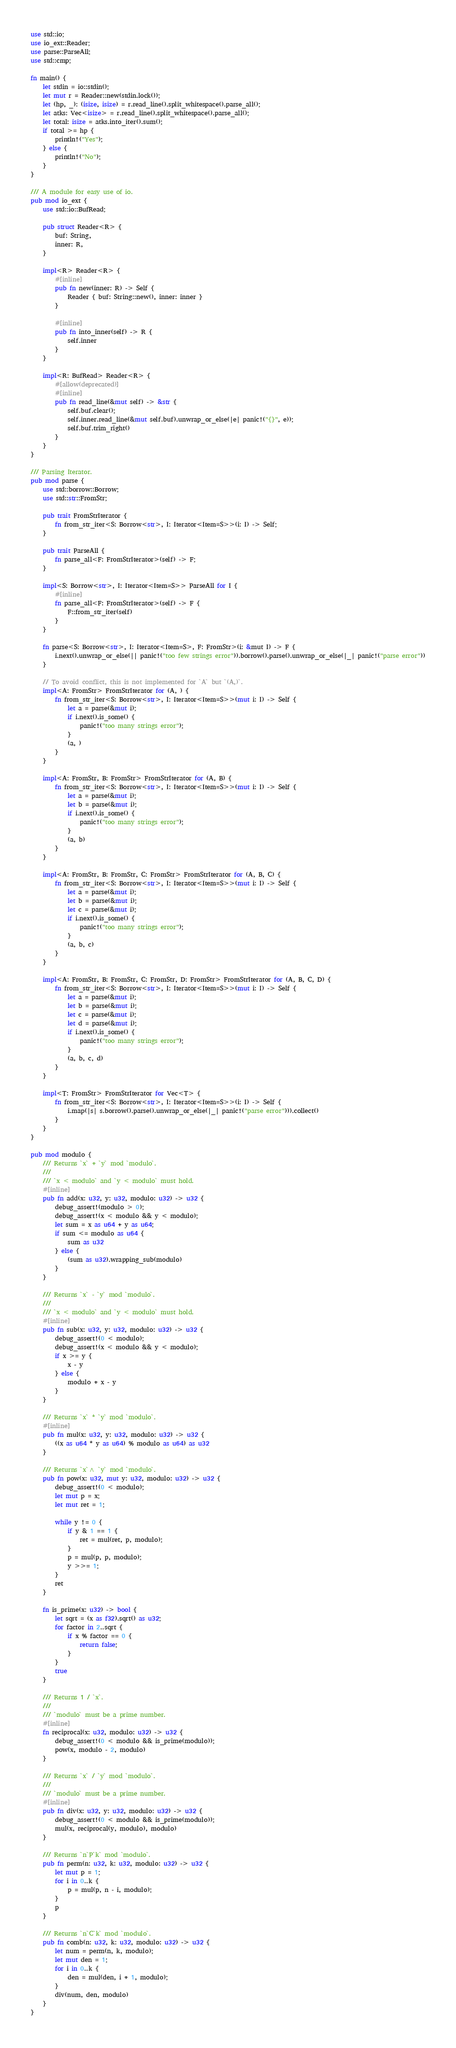<code> <loc_0><loc_0><loc_500><loc_500><_Rust_>use std::io;
use io_ext::Reader;
use parse::ParseAll;
use std::cmp;

fn main() {
    let stdin = io::stdin();
    let mut r = Reader::new(stdin.lock());
    let (hp, _): (isize, isize) = r.read_line().split_whitespace().parse_all();
    let atks: Vec<isize> = r.read_line().split_whitespace().parse_all();
    let total: isize = atks.into_iter().sum();
    if total >= hp {
        println!("Yes");
    } else {
        println!("No");
    }
}

/// A module for easy use of io.
pub mod io_ext {
    use std::io::BufRead;

    pub struct Reader<R> {
        buf: String,
        inner: R,
    }

    impl<R> Reader<R> {
        #[inline]
        pub fn new(inner: R) -> Self {
            Reader { buf: String::new(), inner: inner }
        }

        #[inline]
        pub fn into_inner(self) -> R {
            self.inner
        }
    }

    impl<R: BufRead> Reader<R> {
        #[allow(deprecated)]
        #[inline]
        pub fn read_line(&mut self) -> &str {
            self.buf.clear();
            self.inner.read_line(&mut self.buf).unwrap_or_else(|e| panic!("{}", e));
            self.buf.trim_right()
        }
    }
}

/// Parsing Iterator.
pub mod parse {
    use std::borrow::Borrow;
    use std::str::FromStr;

    pub trait FromStrIterator {
        fn from_str_iter<S: Borrow<str>, I: Iterator<Item=S>>(i: I) -> Self;
    }

    pub trait ParseAll {
        fn parse_all<F: FromStrIterator>(self) -> F;
    }

    impl<S: Borrow<str>, I: Iterator<Item=S>> ParseAll for I {
        #[inline]
        fn parse_all<F: FromStrIterator>(self) -> F {
            F::from_str_iter(self)
        }
    }

    fn parse<S: Borrow<str>, I: Iterator<Item=S>, F: FromStr>(i: &mut I) -> F {
        i.next().unwrap_or_else(|| panic!("too few strings error")).borrow().parse().unwrap_or_else(|_| panic!("parse error"))
    }

    // To avoid conflict, this is not implemented for `A` but `(A,)`.
    impl<A: FromStr> FromStrIterator for (A, ) {
        fn from_str_iter<S: Borrow<str>, I: Iterator<Item=S>>(mut i: I) -> Self {
            let a = parse(&mut i);
            if i.next().is_some() {
                panic!("too many strings error");
            }
            (a, )
        }
    }

    impl<A: FromStr, B: FromStr> FromStrIterator for (A, B) {
        fn from_str_iter<S: Borrow<str>, I: Iterator<Item=S>>(mut i: I) -> Self {
            let a = parse(&mut i);
            let b = parse(&mut i);
            if i.next().is_some() {
                panic!("too many strings error");
            }
            (a, b)
        }
    }

    impl<A: FromStr, B: FromStr, C: FromStr> FromStrIterator for (A, B, C) {
        fn from_str_iter<S: Borrow<str>, I: Iterator<Item=S>>(mut i: I) -> Self {
            let a = parse(&mut i);
            let b = parse(&mut i);
            let c = parse(&mut i);
            if i.next().is_some() {
                panic!("too many strings error");
            }
            (a, b, c)
        }
    }

    impl<A: FromStr, B: FromStr, C: FromStr, D: FromStr> FromStrIterator for (A, B, C, D) {
        fn from_str_iter<S: Borrow<str>, I: Iterator<Item=S>>(mut i: I) -> Self {
            let a = parse(&mut i);
            let b = parse(&mut i);
            let c = parse(&mut i);
            let d = parse(&mut i);
            if i.next().is_some() {
                panic!("too many strings error");
            }
            (a, b, c, d)
        }
    }

    impl<T: FromStr> FromStrIterator for Vec<T> {
        fn from_str_iter<S: Borrow<str>, I: Iterator<Item=S>>(i: I) -> Self {
            i.map(|s| s.borrow().parse().unwrap_or_else(|_| panic!("parse error"))).collect()
        }
    }
}

pub mod modulo {
    /// Returns `x` + `y` mod `modulo`.
    ///
    /// `x < modulo` and `y < modulo` must hold.
    #[inline]
    pub fn add(x: u32, y: u32, modulo: u32) -> u32 {
        debug_assert!(modulo > 0);
        debug_assert!(x < modulo && y < modulo);
        let sum = x as u64 + y as u64;
        if sum <= modulo as u64 {
            sum as u32
        } else {
            (sum as u32).wrapping_sub(modulo)
        }
    }

    /// Returns `x` - `y` mod `modulo`.
    ///
    /// `x < modulo` and `y < modulo` must hold.
    #[inline]
    pub fn sub(x: u32, y: u32, modulo: u32) -> u32 {
        debug_assert!(0 < modulo);
        debug_assert!(x < modulo && y < modulo);
        if x >= y {
            x - y
        } else {
            modulo + x - y
        }
    }

    /// Returns `x` * `y` mod `modulo`.
    #[inline]
    pub fn mul(x: u32, y: u32, modulo: u32) -> u32 {
        ((x as u64 * y as u64) % modulo as u64) as u32
    }

    /// Returns `x`^ `y` mod `modulo`.
    pub fn pow(x: u32, mut y: u32, modulo: u32) -> u32 {
        debug_assert!(0 < modulo);
        let mut p = x;
        let mut ret = 1;

        while y != 0 {
            if y & 1 == 1 {
                ret = mul(ret, p, modulo);
            }
            p = mul(p, p, modulo);
            y >>= 1;
        }
        ret
    }

    fn is_prime(x: u32) -> bool {
        let sqrt = (x as f32).sqrt() as u32;
        for factor in 2..sqrt {
            if x % factor == 0 {
                return false;
            }
        }
        true
    }

    /// Returns 1 / `x`.
    ///
    /// `modulo` must be a prime number.
    #[inline]
    fn reciprocal(x: u32, modulo: u32) -> u32 {
        debug_assert!(0 < modulo && is_prime(modulo));
        pow(x, modulo - 2, modulo)
    }

    /// Returns `x` / `y` mod `modulo`.
    ///
    /// `modulo` must be a prime number.
    #[inline]
    pub fn div(x: u32, y: u32, modulo: u32) -> u32 {
        debug_assert!(0 < modulo && is_prime(modulo));
        mul(x, reciprocal(y, modulo), modulo)
    }

    /// Returns `n`P`k` mod `modulo`.
    pub fn perm(n: u32, k: u32, modulo: u32) -> u32 {
        let mut p = 1;
        for i in 0..k {
            p = mul(p, n - i, modulo);
        }
        p
    }

    /// Returns `n`C`k` mod `modulo`.
    pub fn comb(n: u32, k: u32, modulo: u32) -> u32 {
        let num = perm(n, k, modulo);
        let mut den = 1;
        for i in 0..k {
            den = mul(den, i + 1, modulo);
        }
        div(num, den, modulo)
    }
}</code> 